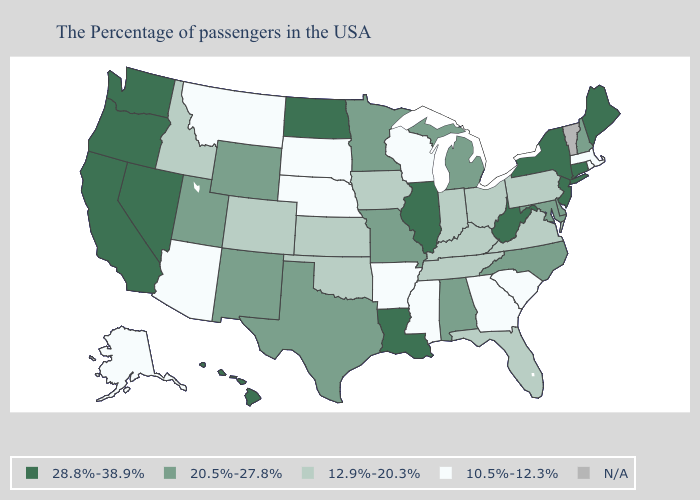Is the legend a continuous bar?
Keep it brief. No. What is the lowest value in the Northeast?
Be succinct. 10.5%-12.3%. What is the value of Washington?
Be succinct. 28.8%-38.9%. Name the states that have a value in the range 10.5%-12.3%?
Give a very brief answer. Massachusetts, Rhode Island, South Carolina, Georgia, Wisconsin, Mississippi, Arkansas, Nebraska, South Dakota, Montana, Arizona, Alaska. Which states have the highest value in the USA?
Give a very brief answer. Maine, Connecticut, New York, New Jersey, West Virginia, Illinois, Louisiana, North Dakota, Nevada, California, Washington, Oregon, Hawaii. What is the lowest value in the USA?
Give a very brief answer. 10.5%-12.3%. What is the highest value in the Northeast ?
Quick response, please. 28.8%-38.9%. Among the states that border Massachusetts , does Rhode Island have the highest value?
Keep it brief. No. Does the map have missing data?
Be succinct. Yes. Which states have the lowest value in the USA?
Give a very brief answer. Massachusetts, Rhode Island, South Carolina, Georgia, Wisconsin, Mississippi, Arkansas, Nebraska, South Dakota, Montana, Arizona, Alaska. Is the legend a continuous bar?
Give a very brief answer. No. Is the legend a continuous bar?
Give a very brief answer. No. 